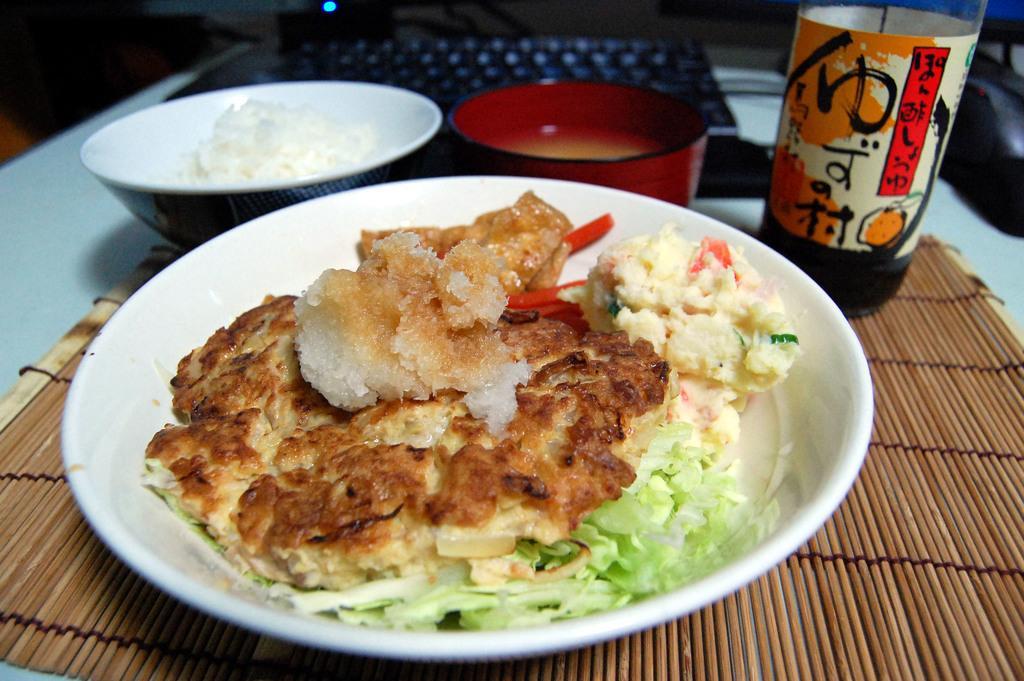How would you summarize this image in a sentence or two? In this image there is a table and we can see bowls, laptop, bottle, dining mat and some food placed placed on the table. 